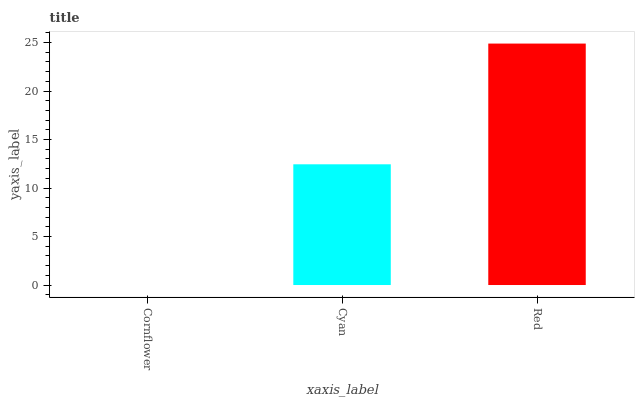Is Cornflower the minimum?
Answer yes or no. Yes. Is Red the maximum?
Answer yes or no. Yes. Is Cyan the minimum?
Answer yes or no. No. Is Cyan the maximum?
Answer yes or no. No. Is Cyan greater than Cornflower?
Answer yes or no. Yes. Is Cornflower less than Cyan?
Answer yes or no. Yes. Is Cornflower greater than Cyan?
Answer yes or no. No. Is Cyan less than Cornflower?
Answer yes or no. No. Is Cyan the high median?
Answer yes or no. Yes. Is Cyan the low median?
Answer yes or no. Yes. Is Red the high median?
Answer yes or no. No. Is Red the low median?
Answer yes or no. No. 